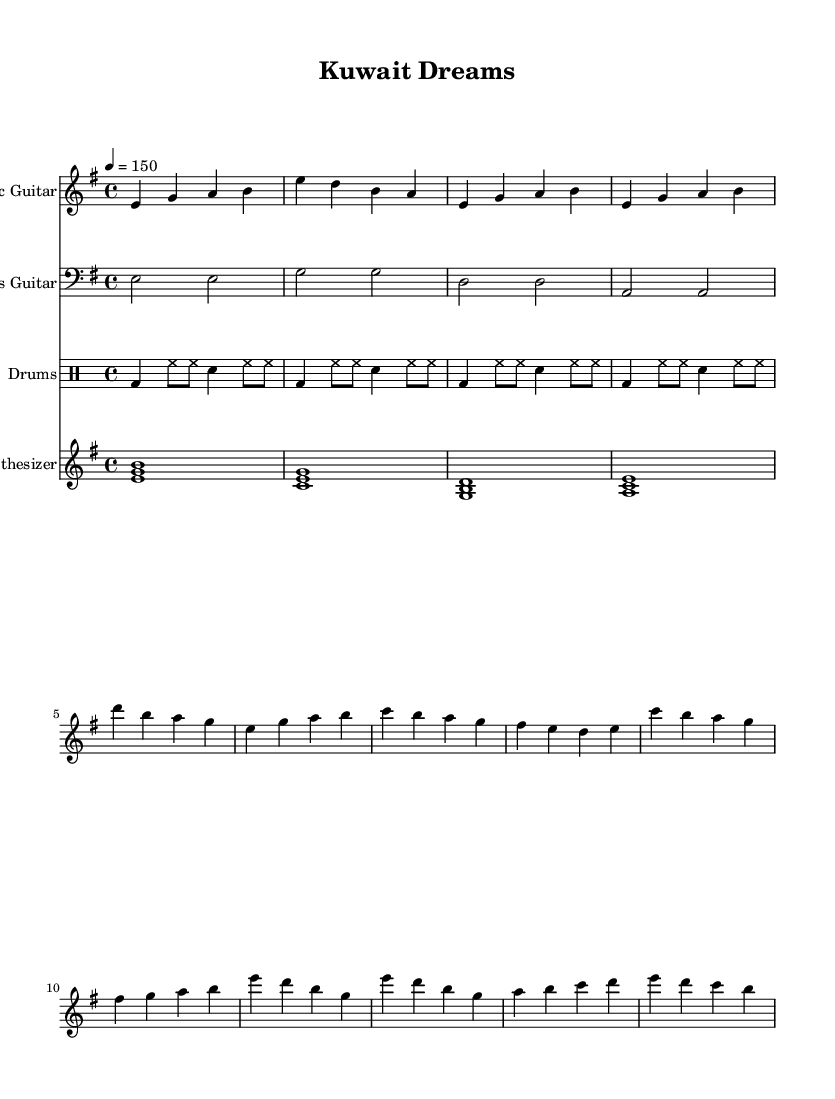What is the key signature of this music? The key signature is E minor, with one sharp (F#). This can be identified at the beginning of the staff where the sharp symbol appears.
Answer: E minor What is the time signature of this music? The time signature is 4/4, indicated at the beginning of the score with two numbers stacked, the upper number being 4 (beats per measure) and the lower number being 4 (the quarter note gets the beat).
Answer: 4/4 What is the tempo marking of this piece? The tempo marking is 150 beats per minute, specified by the "4 = 150" notation that indicates the number of beats per minute.
Answer: 150 How many measures are in the electric guitar part? The electric guitar part consists of 6 measures, counting the number of vertical lines (bar lines) that separate the musical phrases.
Answer: 6 Which instrument plays the bass line? The bass line is played by the Bass Guitar, as indicated at the beginning of the staff where it states the instrument name specifically.
Answer: Bass Guitar What type of rhythm is primarily used in the drums part? The primary rhythm in the drums part consists of a repeating pattern of bass drum and hi-hat, with occasional snare hits, which establishes a driving rhythm typical for hard rock.
Answer: Repeating pattern What is the highest note played in the synthesizer part? The highest note in the synthesizer part is A, as seen in the notation where the pitches range from E to A, confirming A is the highest occurrence.
Answer: A 